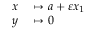<formula> <loc_0><loc_0><loc_500><loc_500>\begin{array} { r l } { x } & \mapsto a + \varepsilon x _ { 1 } } \\ { y } & \mapsto 0 } \end{array}</formula> 